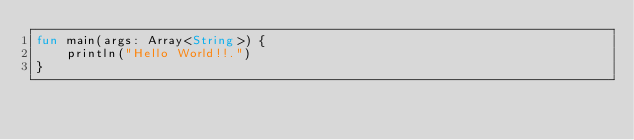<code> <loc_0><loc_0><loc_500><loc_500><_Kotlin_>fun main(args: Array<String>) {
    println("Hello World!!.")
}</code> 